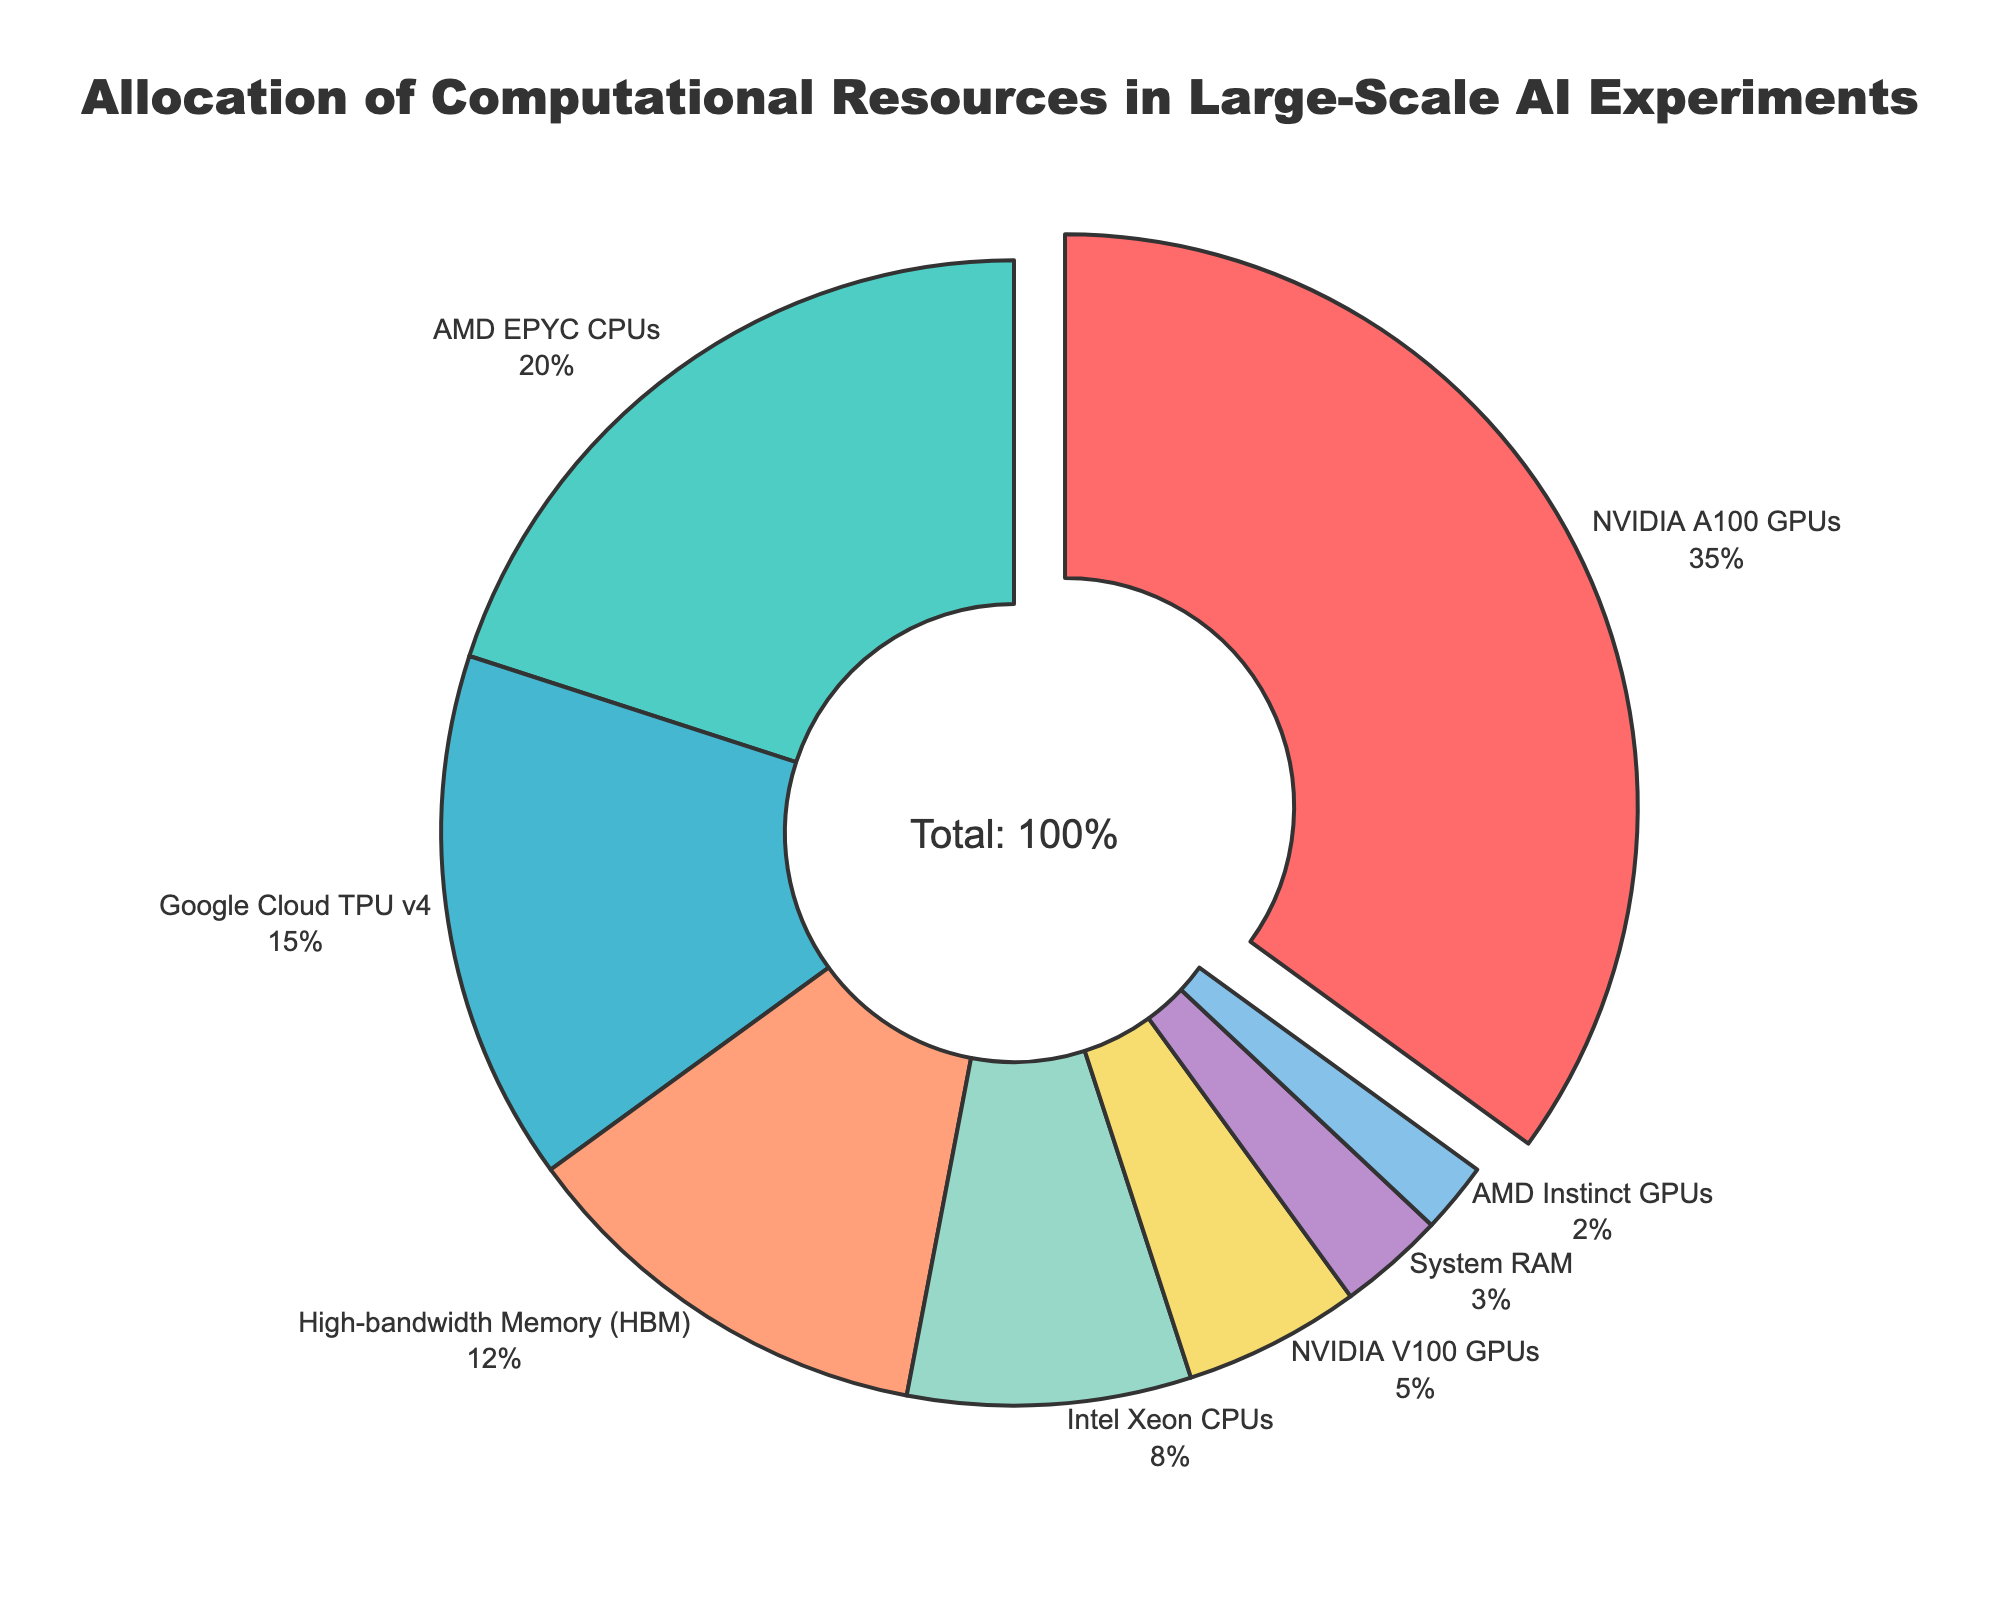What percentage of resources is allocated to NVIDIA A100 GPUs? By observing the pie chart, we can see that the portion labeled "NVIDIA A100 GPUs" has a percentage value.
Answer: 35% Which resource type has the smallest allocation according to the pie chart? We look at the pie chart to find the smallest slice, which is labeled with the resource type and percentage.
Answer: AMD Instinct GPUs What is the total percentage of CPU resources (both AMD EPYC and Intel Xeon)? Add the percentage values for "AMD EPYC CPUs" and "Intel Xeon CPUs": 20% + 8%.
Answer: 28% How much more resource allocation does NVIDIA A100 GPUs have compared to NVIDIA V100 GPUs? Subtract the percentage of NVIDIA V100 GPUs from NVIDIA A100 GPUs: 35% - 5%.
Answer: 30% Which resource type has a higher allocation: System RAM or High-bandwidth Memory (HBM)? Compare the percentages for "System RAM" and "High-bandwidth Memory (HBM)" directly from the pie chart.
Answer: High-bandwidth Memory (HBM) Combine the percentage values of GPUs (NVIDIA A100, NVIDIA V100, AMD Instinct) and find the total. Sum the percentages for NVIDIA A100 GPUs, NVIDIA V100 GPUs, and AMD Instinct GPUs: 35% + 5% + 2%.
Answer: 42% Which slice is visually represented with a pull effect and why? The largest slice in the pie chart is pulled out for emphasis. According to the data, "NVIDIA A100 GPUs" has the highest percentage, so it is pulled out.
Answer: NVIDIA A100 GPUs What is the average percentage allocation of the three most allocated resource types? Determine the three largest percentages: 35%, 20%, and 15%, then sum and divide by 3: (35 + 20 + 15) / 3.
Answer: 23.33% Are the resources allocated to CPUs more or less than half of the total resources? Add the percentages of all CPU types: AMD EPYC CPUs (20%) + Intel Xeon CPUs (8%); compare the sum (28%) to half of the total (50%).
Answer: Less 